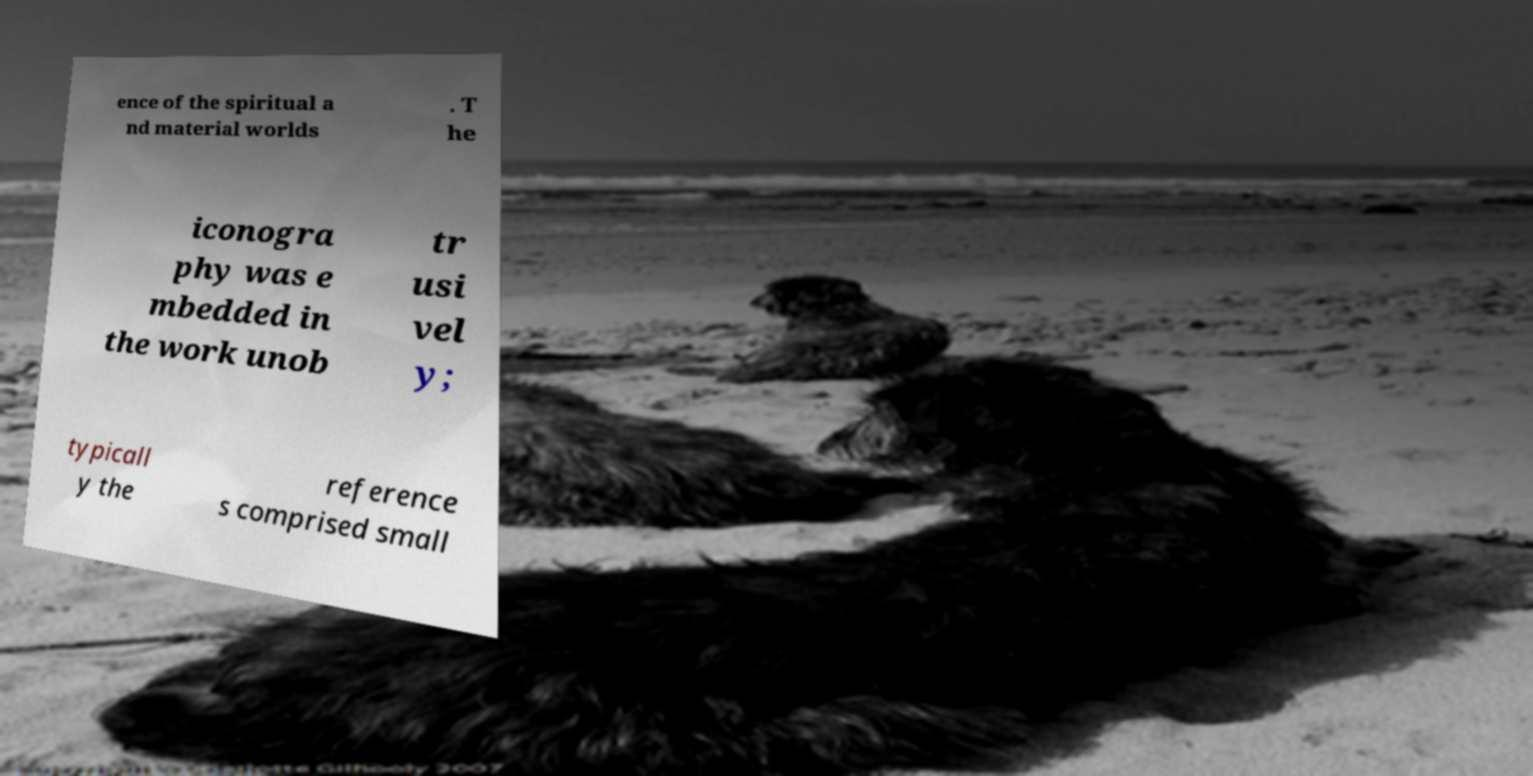Could you assist in decoding the text presented in this image and type it out clearly? ence of the spiritual a nd material worlds . T he iconogra phy was e mbedded in the work unob tr usi vel y; typicall y the reference s comprised small 